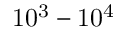<formula> <loc_0><loc_0><loc_500><loc_500>1 0 ^ { 3 } - 1 0 ^ { 4 }</formula> 